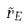<formula> <loc_0><loc_0><loc_500><loc_500>\tilde { r } _ { E }</formula> 